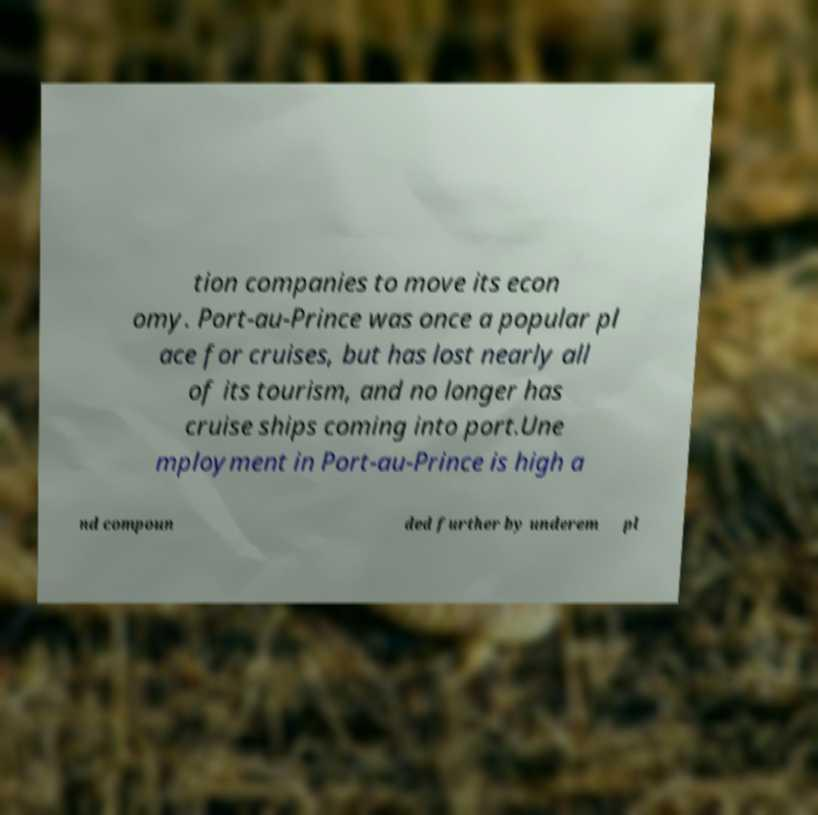There's text embedded in this image that I need extracted. Can you transcribe it verbatim? tion companies to move its econ omy. Port-au-Prince was once a popular pl ace for cruises, but has lost nearly all of its tourism, and no longer has cruise ships coming into port.Une mployment in Port-au-Prince is high a nd compoun ded further by underem pl 